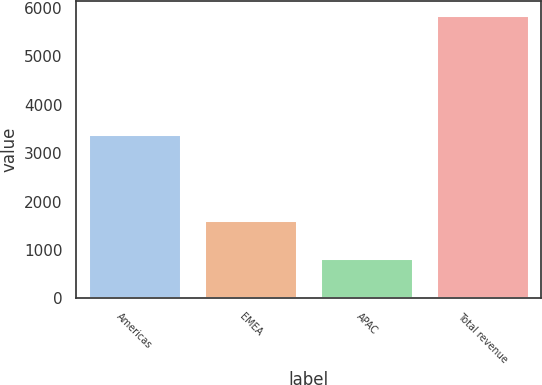Convert chart to OTSL. <chart><loc_0><loc_0><loc_500><loc_500><bar_chart><fcel>Americas<fcel>EMEA<fcel>APAC<fcel>Total revenue<nl><fcel>3400.1<fcel>1619.2<fcel>835.1<fcel>5854.4<nl></chart> 